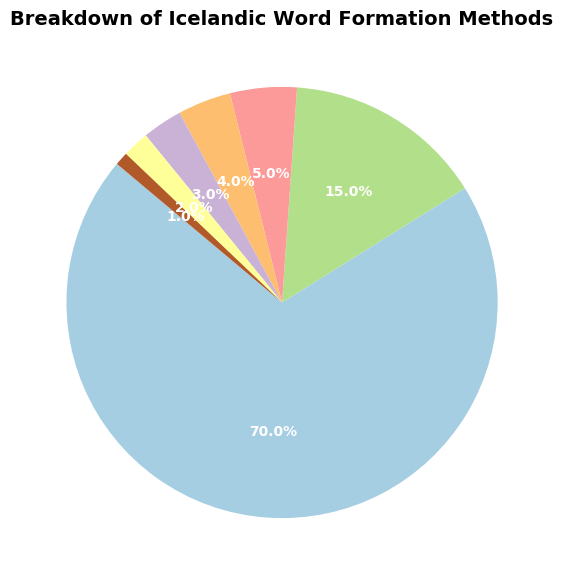What's the most common word formation method in Icelandic? The pie chart shows the breakdown of different word formation methods, and the largest wedge corresponds to Compounding, indicating it is the most common method.
Answer: Compounding What percentage of Icelandic words are formed by affixation and derivation combined? To find the combined percentage, add the percentages of affixation and derivation. According to the chart, affixation is 15% and derivation is 5%, so their sum is 15% + 5% = 20%.
Answer: 20% Comparing borrowing and clipping, which method contributes less to Icelandic word formation? The pie chart shows the percentages for each method. Borrowing is 4%, and clipping is 3%. Since 3% is less than 4%, clipping contributes less.
Answer: Clipping What is the difference in percentage between the most and the least common word formation methods? The most common method is Compounding at 70%, and the least common is Reduplication at 1%. The difference is calculated as 70% - 1% = 69%.
Answer: 69% How does the percentage of words formed by compounding compare to the sum of the percentages of borrowing, clipping, coinage, and reduplication? First, find the sum of borrowing, clipping, coinage, and reduplication: 4% + 3% + 2% + 1% = 10%. Compounding is 70%, which is significantly greater than 10%.
Answer: Compounding is greater How many times larger is the percentage of compounding than that of coinage? The percentage for compounding is 70% and for coinage is 2%. The ratio is 70% / 2%, which equals 35. Compounding is 35 times larger than coinage.
Answer: 35 times Which methods together make up less than 10% of Icelandic word formation? From the chart, the methods with percentages less than 10% are Derivation (5%), Borrowing (4%), Clipping (3%), Coinage (2%), and Reduplication (1%). Together, they sum to 5% + 4% + 3% + 2% + 1% = 15%. Hence, no single combination makes up less than 10%, but each individually except derivation is less than 10%.
Answer: Borrowing, Clipping, Coinage, Reduplication 